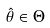Convert formula to latex. <formula><loc_0><loc_0><loc_500><loc_500>\hat { \theta } \in \Theta</formula> 